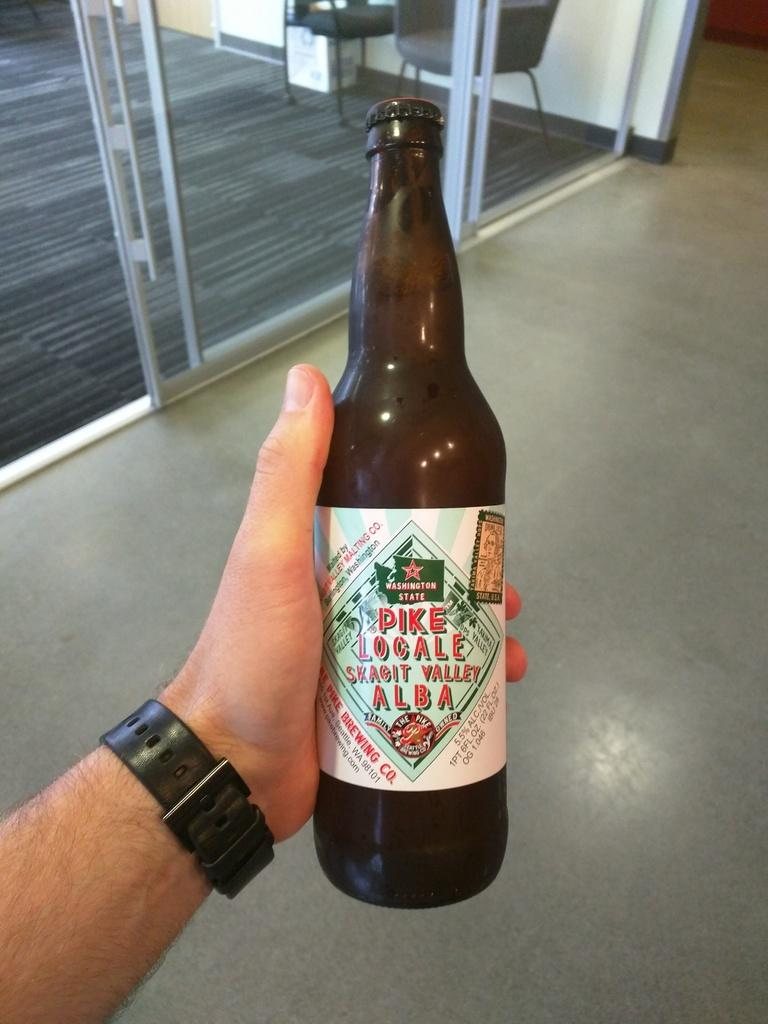<image>
Give a short and clear explanation of the subsequent image. A person holds a bottle of beer that has Washington state on the label 